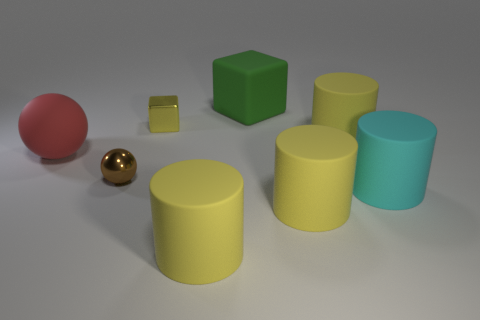Is there a gray thing made of the same material as the red object?
Your answer should be very brief. No. Do the large cylinder behind the rubber ball and the block that is in front of the big block have the same color?
Provide a succinct answer. Yes. Are there fewer big matte cylinders that are on the left side of the green rubber block than shiny objects?
Offer a terse response. Yes. How many things are green cubes or big yellow rubber cylinders that are on the right side of the large green thing?
Offer a terse response. 3. There is a cube that is made of the same material as the brown ball; what is its color?
Offer a very short reply. Yellow. How many objects are tiny blue rubber cylinders or yellow metal things?
Your answer should be very brief. 1. The block that is the same size as the cyan object is what color?
Offer a very short reply. Green. What number of things are either large yellow rubber cylinders behind the cyan rubber cylinder or cyan matte cylinders?
Your response must be concise. 2. How many other objects are the same size as the red matte thing?
Keep it short and to the point. 5. What size is the brown metallic sphere that is in front of the large red object?
Provide a succinct answer. Small. 